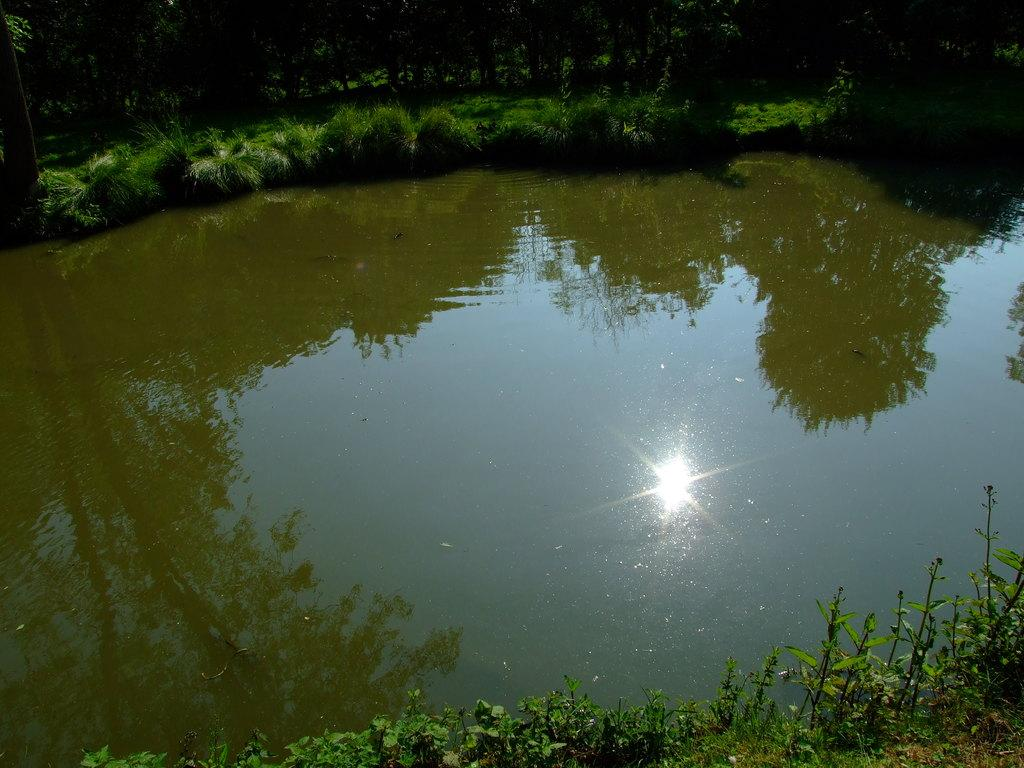What is there is a body of water in the foreground of the image. What is it? There is a pond in the foreground of the image. What can be seen around the pond? There is greenery around the pond. Can you describe the reflection in the water? The sun is visible in the water reflection. Is there a bear swimming in the pond in the image? No, there is no bear present in the image. 